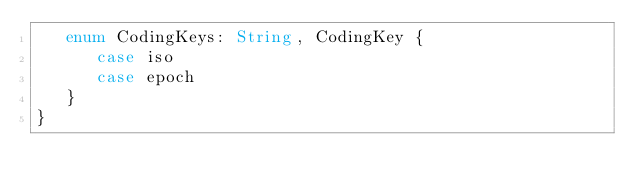<code> <loc_0><loc_0><loc_500><loc_500><_Swift_>   enum CodingKeys: String, CodingKey {
      case iso
      case epoch
   }
}
</code> 